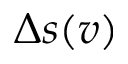Convert formula to latex. <formula><loc_0><loc_0><loc_500><loc_500>\Delta s ( v )</formula> 